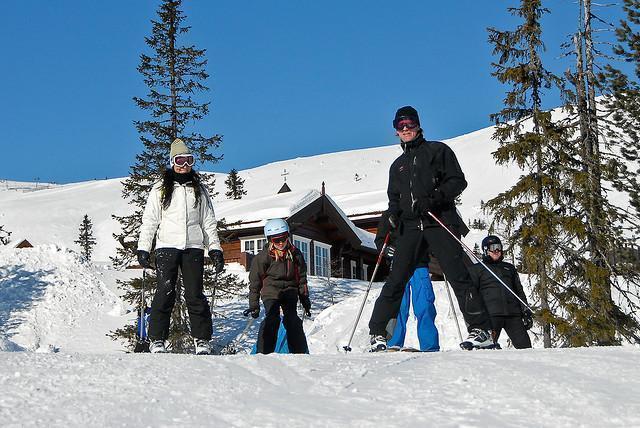Why are the children's heads covered?
Select the accurate answer and provide justification: `Answer: choice
Rationale: srationale.`
Options: Visibility, fashion, protection, religion. Answer: protection.
Rationale: The children are skiing. they are wearing safety helmets. 